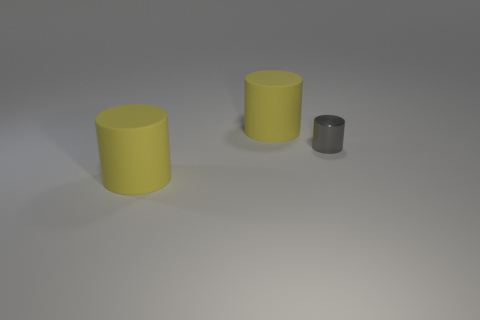Subtract all big matte cylinders. How many cylinders are left? 1 Add 3 metallic objects. How many objects exist? 6 Subtract all yellow cylinders. How many cylinders are left? 1 Subtract all green blocks. How many yellow cylinders are left? 2 Add 3 small brown metal cubes. How many small brown metal cubes exist? 3 Subtract 0 green spheres. How many objects are left? 3 Subtract 2 cylinders. How many cylinders are left? 1 Subtract all cyan cylinders. Subtract all purple blocks. How many cylinders are left? 3 Subtract all small objects. Subtract all red cylinders. How many objects are left? 2 Add 2 yellow matte objects. How many yellow matte objects are left? 4 